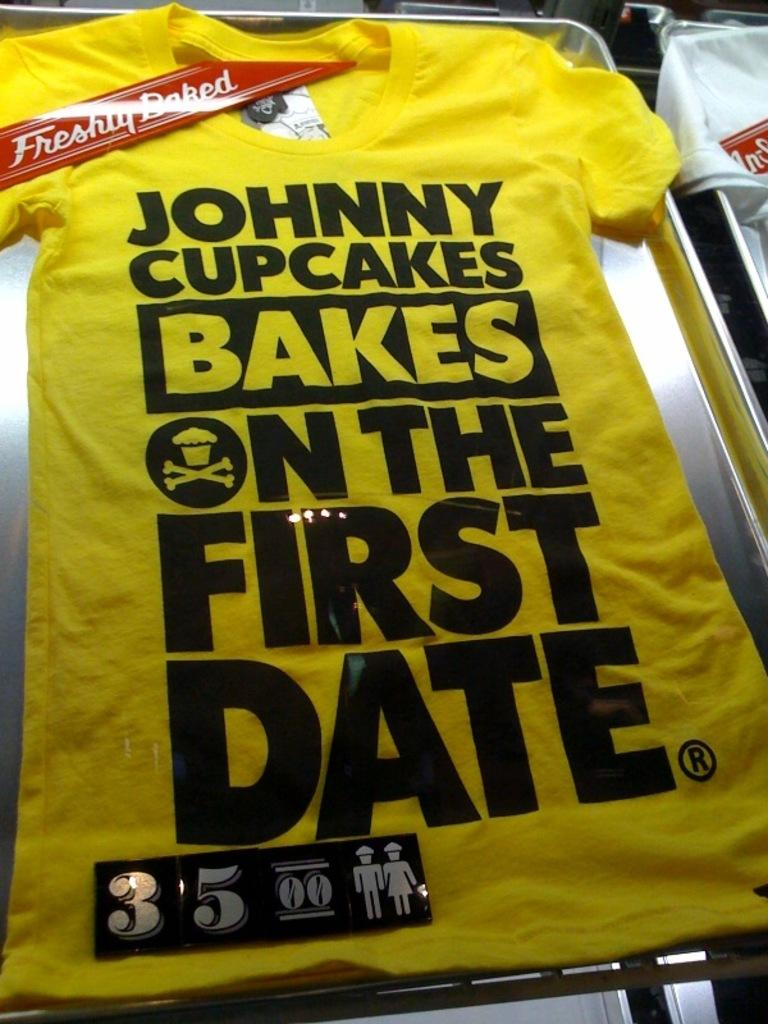Provide a one-sentence caption for the provided image. A yellow shirt says that Johnny Cupcakes bakes on the first date. 